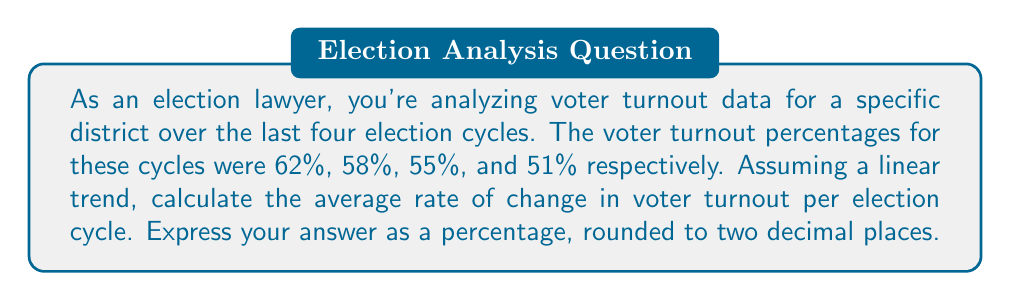Provide a solution to this math problem. To solve this problem, we'll use the concept of average rate of change. The formula for average rate of change is:

$$ \text{Average rate of change} = \frac{\text{Change in y}}{\text{Change in x}} $$

In this case:
- y represents the voter turnout percentage
- x represents the election cycle (we can number them 1, 2, 3, 4 for simplicity)

Let's follow these steps:

1) Identify the first and last data points:
   First point: (1, 62%)
   Last point: (4, 51%)

2) Calculate the change in y (voter turnout):
   $\Delta y = 51\% - 62\% = -11\%$

3) Calculate the change in x (election cycles):
   $\Delta x = 4 - 1 = 3$

4) Apply the average rate of change formula:
   $$ \text{Average rate of change} = \frac{-11\%}{3} = -3.6667\% $$

5) Round to two decimal places:
   $-3.67\%$

The negative sign indicates a decreasing trend in voter turnout.
Answer: $-3.67\%$ per election cycle 